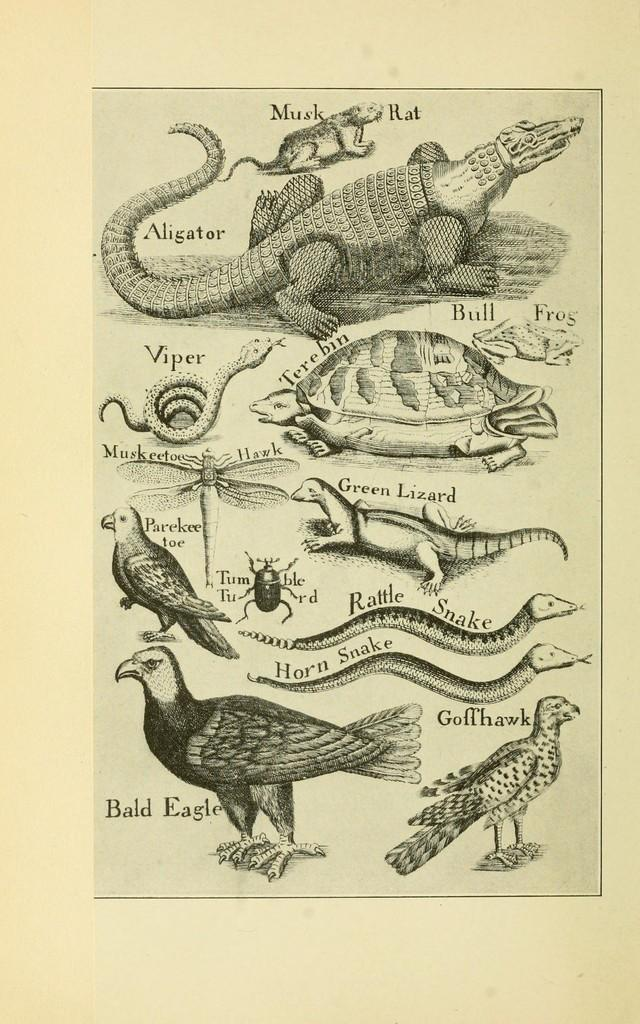What is the main subject of the image? The main subject of the image is a depiction of animals. How can the viewer identify the different animals in the image? The names of the animals are written next to their respective pictures. Are there any laborers working in the image? There is no mention of laborers or any human figures in the image; it only features animals and their names. Can you see any giants in the image? There are no giants or any mythical creatures present in the image; it only features animals and their names. 